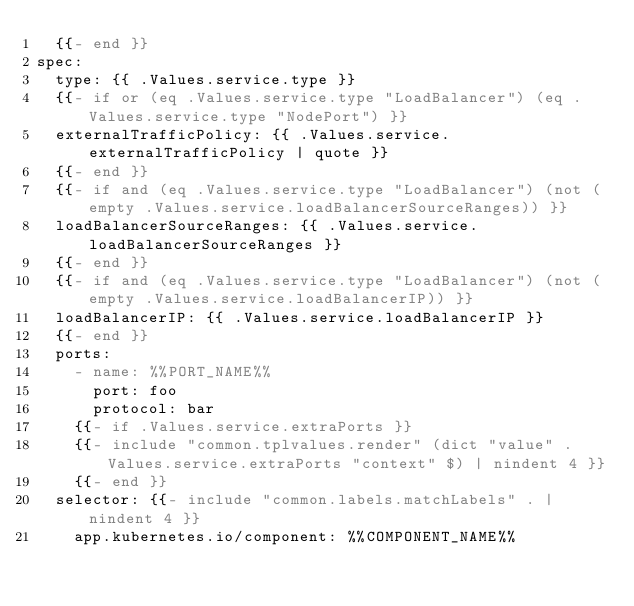Convert code to text. <code><loc_0><loc_0><loc_500><loc_500><_YAML_>  {{- end }}
spec:
  type: {{ .Values.service.type }}
  {{- if or (eq .Values.service.type "LoadBalancer") (eq .Values.service.type "NodePort") }}
  externalTrafficPolicy: {{ .Values.service.externalTrafficPolicy | quote }}
  {{- end }}
  {{- if and (eq .Values.service.type "LoadBalancer") (not (empty .Values.service.loadBalancerSourceRanges)) }}
  loadBalancerSourceRanges: {{ .Values.service.loadBalancerSourceRanges }}
  {{- end }}
  {{- if and (eq .Values.service.type "LoadBalancer") (not (empty .Values.service.loadBalancerIP)) }}
  loadBalancerIP: {{ .Values.service.loadBalancerIP }}
  {{- end }}
  ports:
    - name: %%PORT_NAME%%
      port: foo
      protocol: bar
    {{- if .Values.service.extraPorts }}
    {{- include "common.tplvalues.render" (dict "value" .Values.service.extraPorts "context" $) | nindent 4 }}
    {{- end }}
  selector: {{- include "common.labels.matchLabels" . | nindent 4 }}
    app.kubernetes.io/component: %%COMPONENT_NAME%%
</code> 